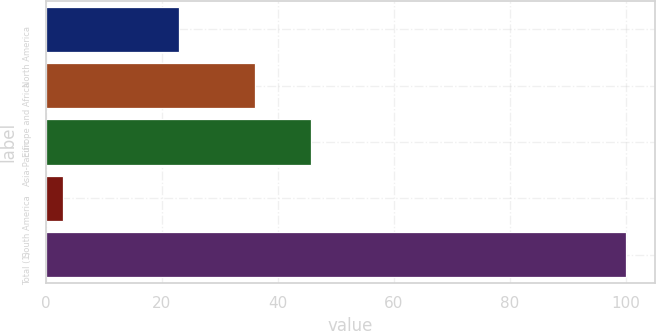Convert chart to OTSL. <chart><loc_0><loc_0><loc_500><loc_500><bar_chart><fcel>North America<fcel>Europe and Africa<fcel>Asia-Pacific<fcel>South America<fcel>Total (1)<nl><fcel>23<fcel>36<fcel>45.7<fcel>3<fcel>100<nl></chart> 